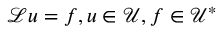Convert formula to latex. <formula><loc_0><loc_0><loc_500><loc_500>\mathcal { L } u = f , u \in \mathcal { U } , f \in \mathcal { U } ^ { * }</formula> 